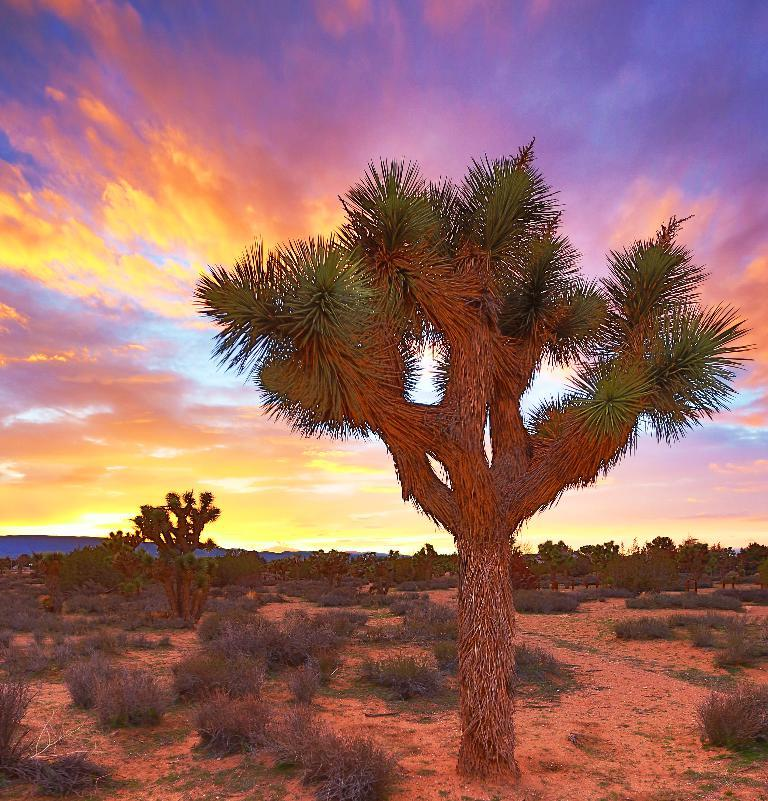What type of artwork is depicted in the image? The image appears to be a painting. What can be seen in the foreground of the painting? There are plants and a tree in the foreground of the painting. What is visible in the background of the painting? There is a sky visible in the background of the painting. What other elements can be seen in the background of the painting? There are plants and trees in the background of the painting. What type of linen is used to create the texture of the plants in the painting? The image is a painting, not a photograph, so there is no linen used in its creation. The texture of the plants is achieved through the artist's brushstrokes and choice of colors. Can you tell me how much cheese is present in the painting? There is no cheese present in the painting; it features plants, trees, and a sky. 